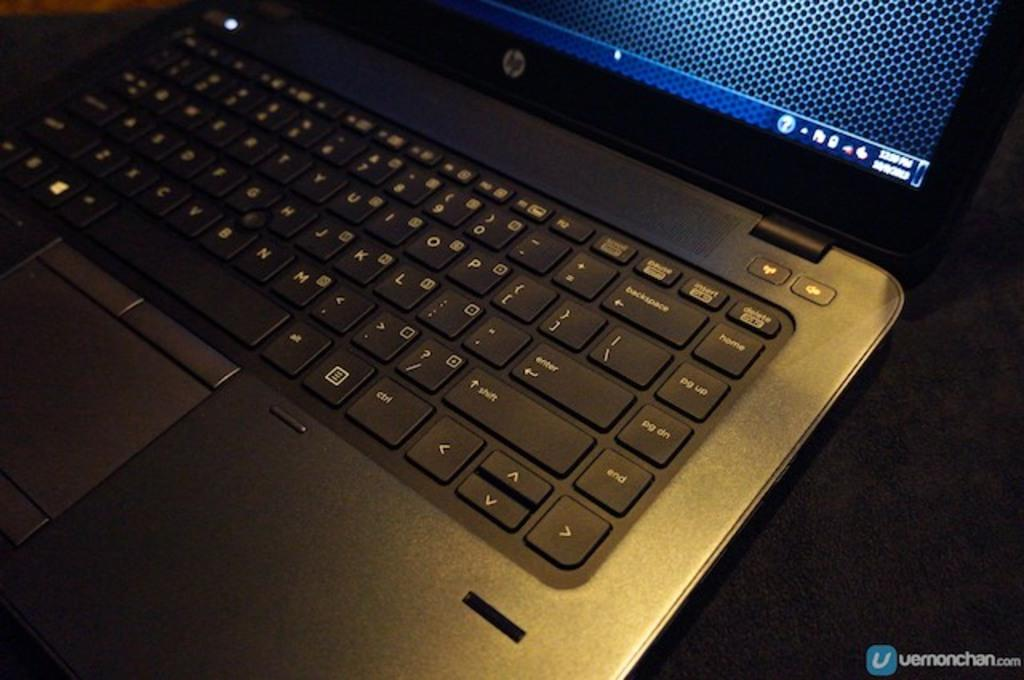Provide a one-sentence caption for the provided image. A laptop that is turned on with a HP logo on it. 